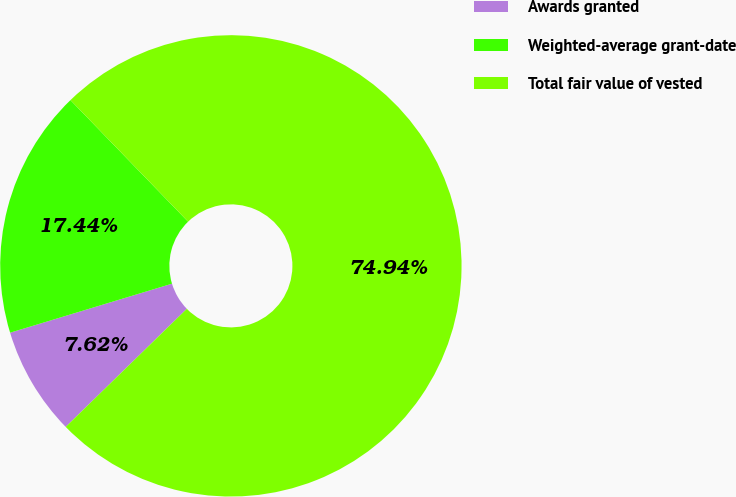<chart> <loc_0><loc_0><loc_500><loc_500><pie_chart><fcel>Awards granted<fcel>Weighted-average grant-date<fcel>Total fair value of vested<nl><fcel>7.62%<fcel>17.44%<fcel>74.94%<nl></chart> 